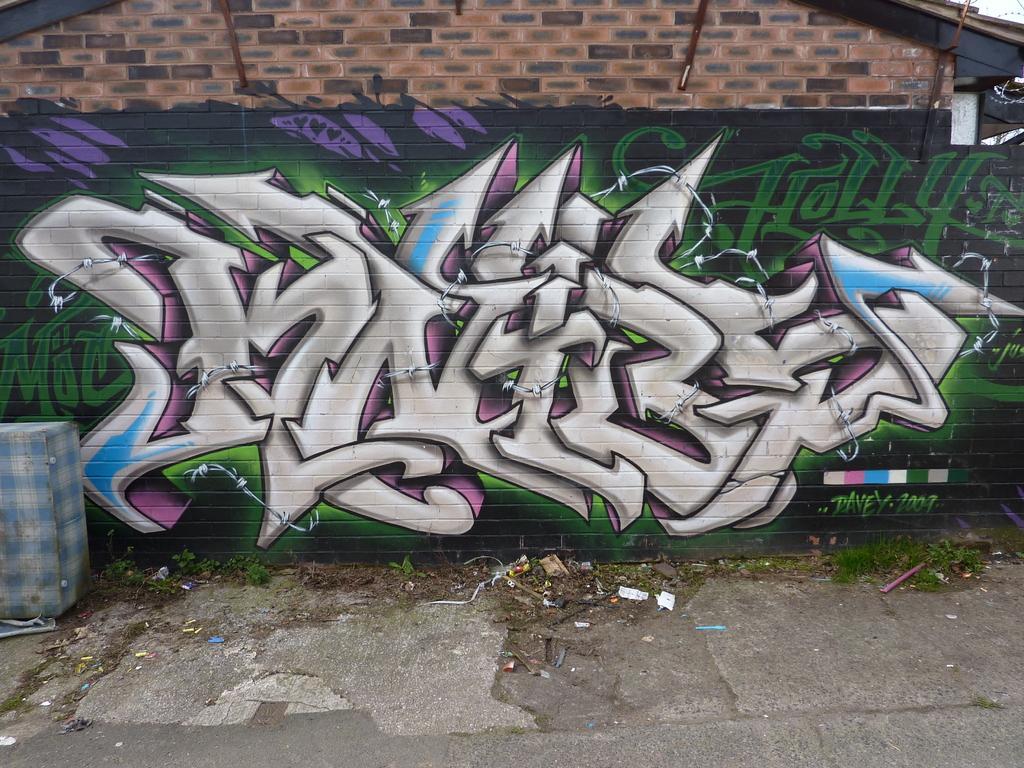How would you summarize this image in a sentence or two? In this picture we can see the brick wall. On the brick walls we can see painting. At the bottom we can see garbage. In the bottom left corner there is a box. In the top right corner there is a sky. 